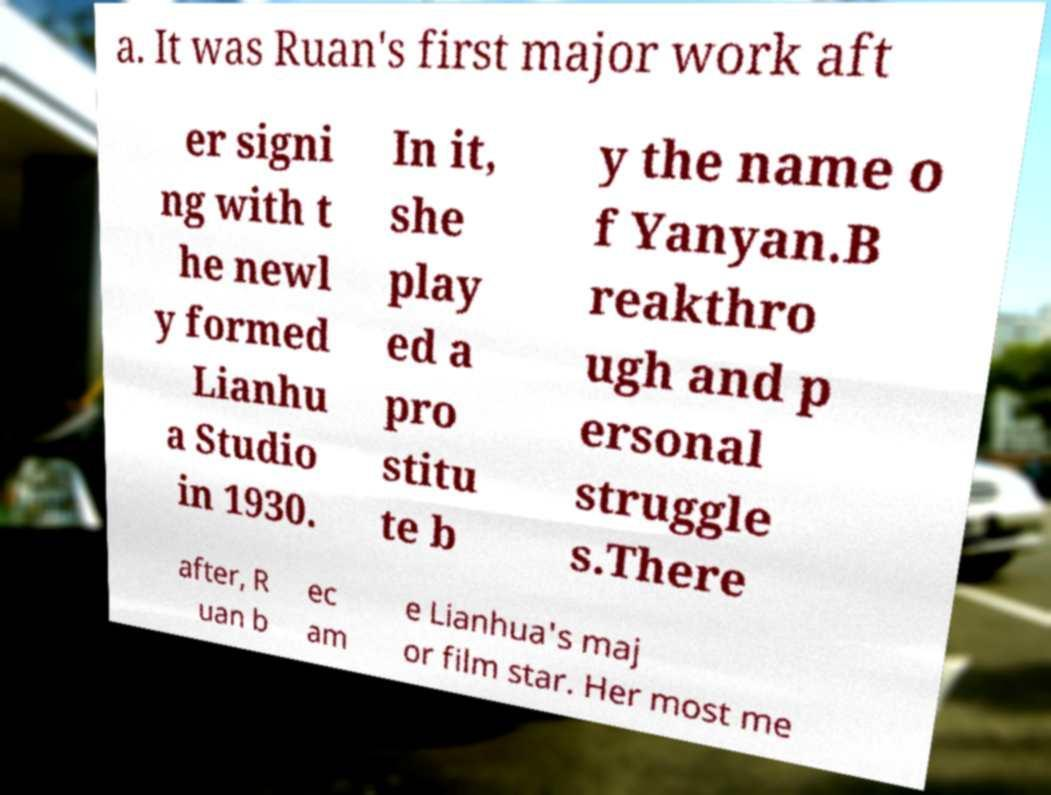There's text embedded in this image that I need extracted. Can you transcribe it verbatim? a. It was Ruan's first major work aft er signi ng with t he newl y formed Lianhu a Studio in 1930. In it, she play ed a pro stitu te b y the name o f Yanyan.B reakthro ugh and p ersonal struggle s.There after, R uan b ec am e Lianhua's maj or film star. Her most me 